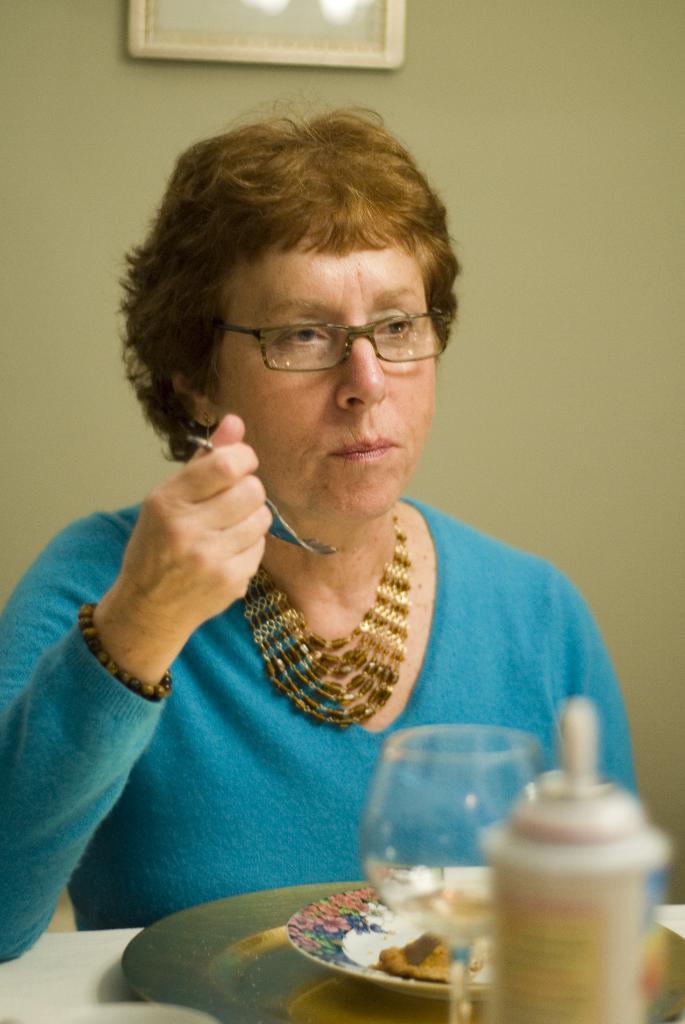Please provide a concise description of this image. In this image there is a table, on that table there are plates and glass, bottles, behind the table there is a lady sitting on a chair, holding a fork in her hand, in the background there is a wall for that wall there is a frame. 